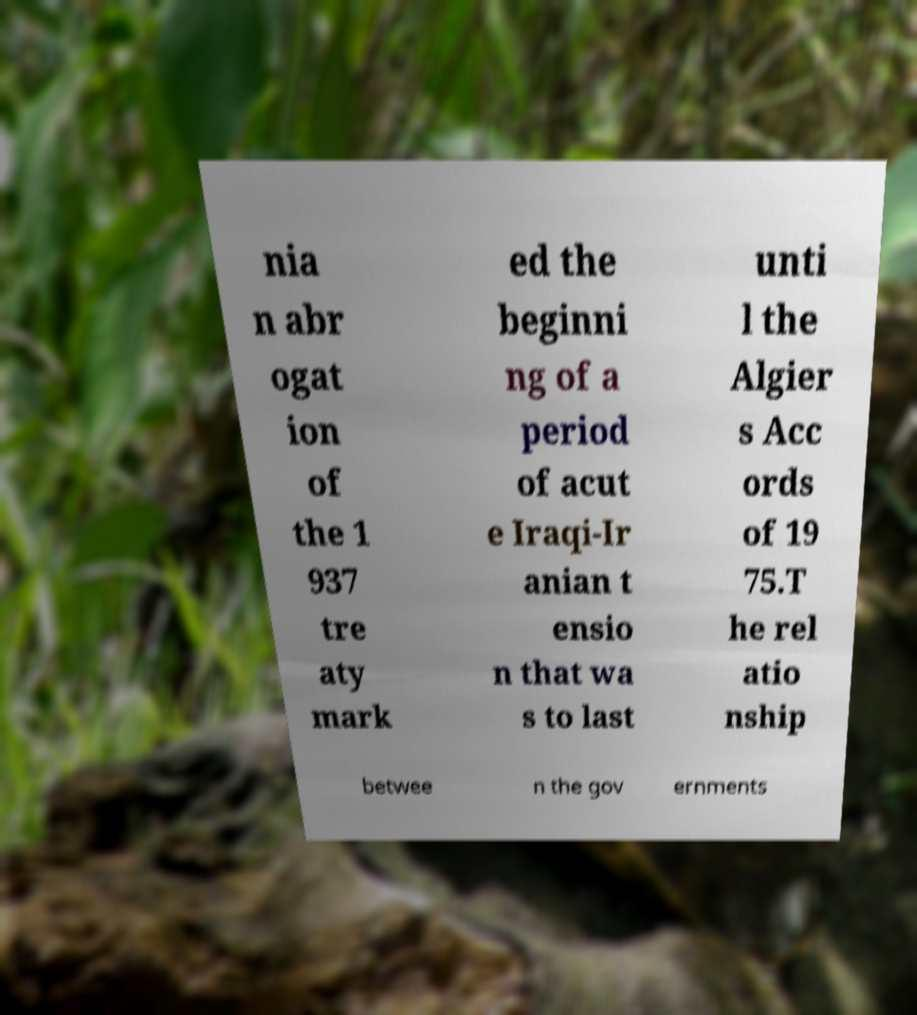I need the written content from this picture converted into text. Can you do that? nia n abr ogat ion of the 1 937 tre aty mark ed the beginni ng of a period of acut e Iraqi-Ir anian t ensio n that wa s to last unti l the Algier s Acc ords of 19 75.T he rel atio nship betwee n the gov ernments 